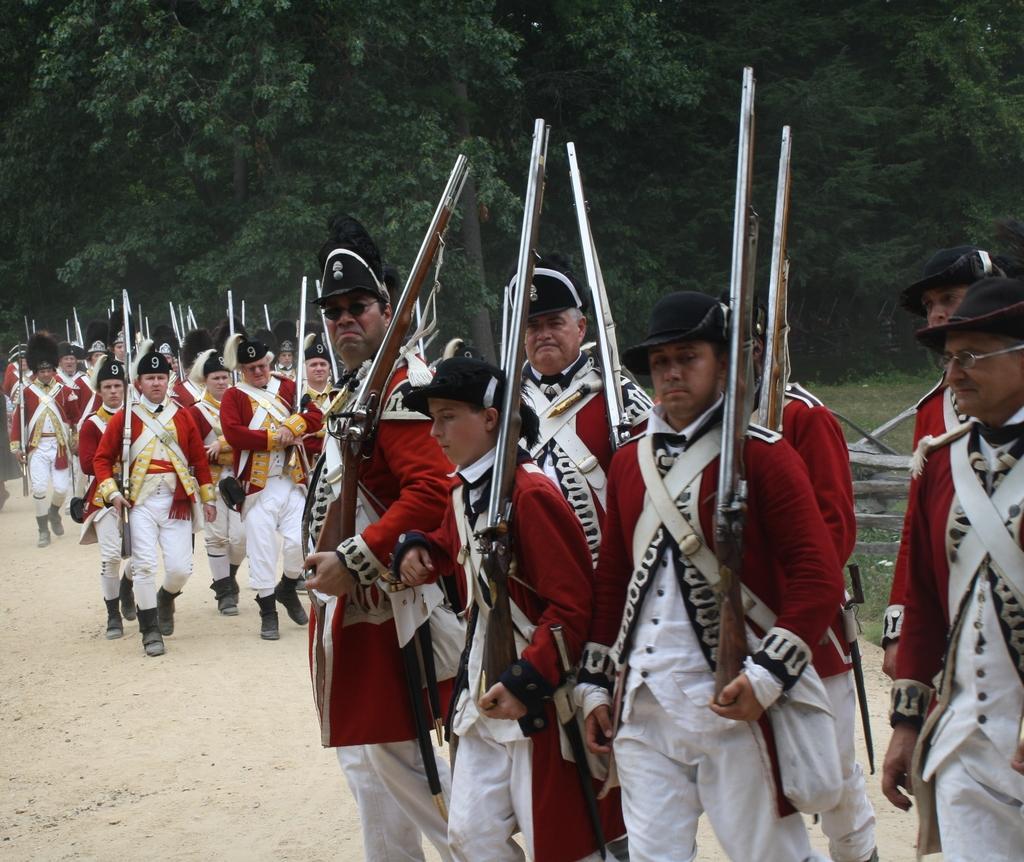In one or two sentences, can you explain what this image depicts? This picture is clicked outside and we can see the group of people wearing uniforms and holding rifles. In the background we can see the trees and some other objects. 